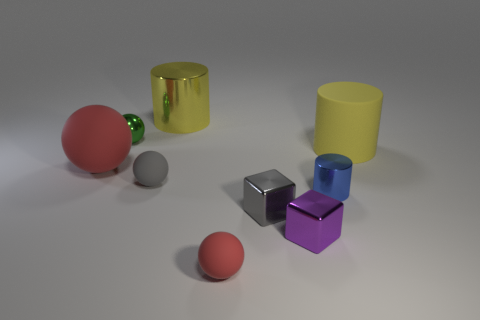The cylinder that is the same material as the tiny blue object is what color?
Provide a short and direct response. Yellow. How many things are shiny cylinders or gray rubber things?
Ensure brevity in your answer.  3. There is a matte object that is the same size as the gray rubber ball; what is its color?
Your answer should be very brief. Red. What number of objects are either purple metal objects in front of the blue object or big cyan matte objects?
Your response must be concise. 1. What number of other objects are there of the same size as the blue metallic thing?
Give a very brief answer. 5. There is a cylinder that is on the left side of the tiny red rubber ball; how big is it?
Keep it short and to the point. Large. There is a gray object that is made of the same material as the purple object; what is its shape?
Keep it short and to the point. Cube. Is there any other thing of the same color as the large matte sphere?
Make the answer very short. Yes. What is the color of the tiny ball that is behind the thing that is on the right side of the small blue object?
Your answer should be very brief. Green. How many tiny things are gray metal blocks or purple blocks?
Provide a succinct answer. 2. 